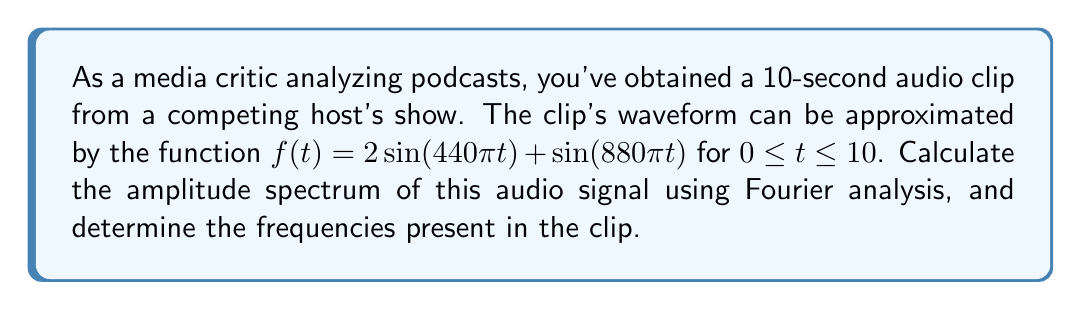Can you solve this math problem? To analyze the frequency spectrum of the audio signal, we'll use the Fourier transform. The steps are as follows:

1) The given function is already in the form of a sum of sinusoids:
   $f(t) = 2\sin(440\pi t) + \sin(880\pi t)$

2) Recall that $\sin(\omega t)$ corresponds to a frequency of $\frac{\omega}{2\pi}$ Hz. So we can identify the frequencies:
   
   For $2\sin(440\pi t)$: $\frac{440\pi}{2\pi} = 220$ Hz
   For $\sin(880\pi t)$: $\frac{880\pi}{2\pi} = 440$ Hz

3) The amplitude spectrum shows the magnitude of each frequency component:
   
   At 220 Hz: amplitude = 2
   At 440 Hz: amplitude = 1

4) In the frequency domain, this would be represented as:

   $$F(\omega) = 2\delta(\omega - 220) + 2\delta(\omega + 220) + \delta(\omega - 440) + \delta(\omega + 440)$$

   Where $\delta$ is the Dirac delta function.

5) The amplitude spectrum is the magnitude of this, which gives us two positive peaks:

   $$|F(\omega)| = 2\delta(\omega - 220) + \delta(\omega - 440)$$

This spectrum shows that the audio clip contains two pure tones: one at 220 Hz with amplitude 2, and another at 440 Hz with amplitude 1.
Answer: Amplitude spectrum: $|F(\omega)| = 2\delta(\omega - 220) + \delta(\omega - 440)$
Frequencies: 220 Hz and 440 Hz 